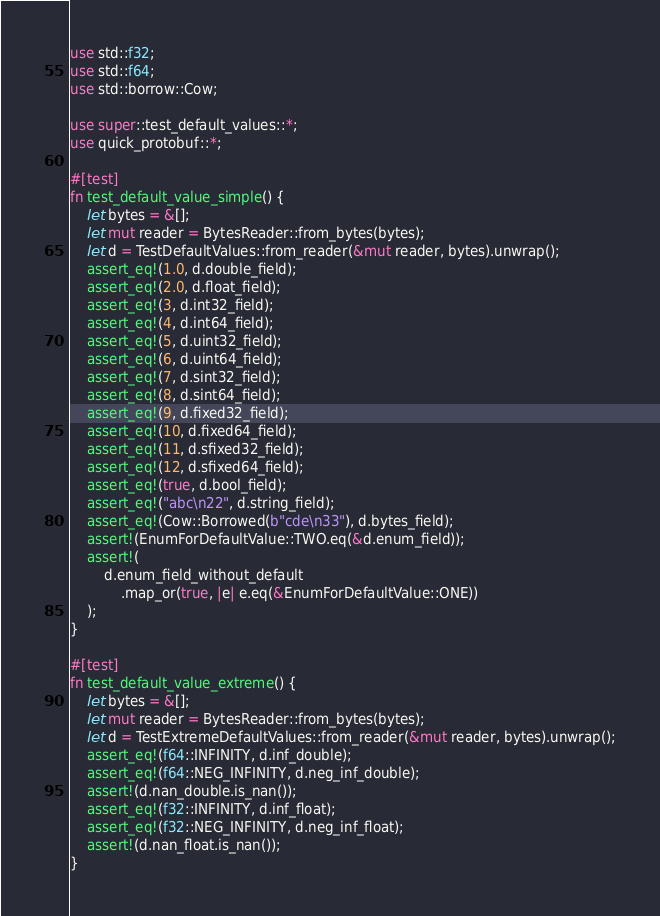<code> <loc_0><loc_0><loc_500><loc_500><_Rust_>use std::f32;
use std::f64;
use std::borrow::Cow;

use super::test_default_values::*;
use quick_protobuf::*;

#[test]
fn test_default_value_simple() {
    let bytes = &[];
    let mut reader = BytesReader::from_bytes(bytes);
    let d = TestDefaultValues::from_reader(&mut reader, bytes).unwrap();
    assert_eq!(1.0, d.double_field);
    assert_eq!(2.0, d.float_field);
    assert_eq!(3, d.int32_field);
    assert_eq!(4, d.int64_field);
    assert_eq!(5, d.uint32_field);
    assert_eq!(6, d.uint64_field);
    assert_eq!(7, d.sint32_field);
    assert_eq!(8, d.sint64_field);
    assert_eq!(9, d.fixed32_field);
    assert_eq!(10, d.fixed64_field);
    assert_eq!(11, d.sfixed32_field);
    assert_eq!(12, d.sfixed64_field);
    assert_eq!(true, d.bool_field);
    assert_eq!("abc\n22", d.string_field);
    assert_eq!(Cow::Borrowed(b"cde\n33"), d.bytes_field);
    assert!(EnumForDefaultValue::TWO.eq(&d.enum_field));
    assert!(
        d.enum_field_without_default
            .map_or(true, |e| e.eq(&EnumForDefaultValue::ONE))
    );
}

#[test]
fn test_default_value_extreme() {
    let bytes = &[];
    let mut reader = BytesReader::from_bytes(bytes);
    let d = TestExtremeDefaultValues::from_reader(&mut reader, bytes).unwrap();
    assert_eq!(f64::INFINITY, d.inf_double);
    assert_eq!(f64::NEG_INFINITY, d.neg_inf_double);
    assert!(d.nan_double.is_nan());
    assert_eq!(f32::INFINITY, d.inf_float);
    assert_eq!(f32::NEG_INFINITY, d.neg_inf_float);
    assert!(d.nan_float.is_nan());
}
</code> 